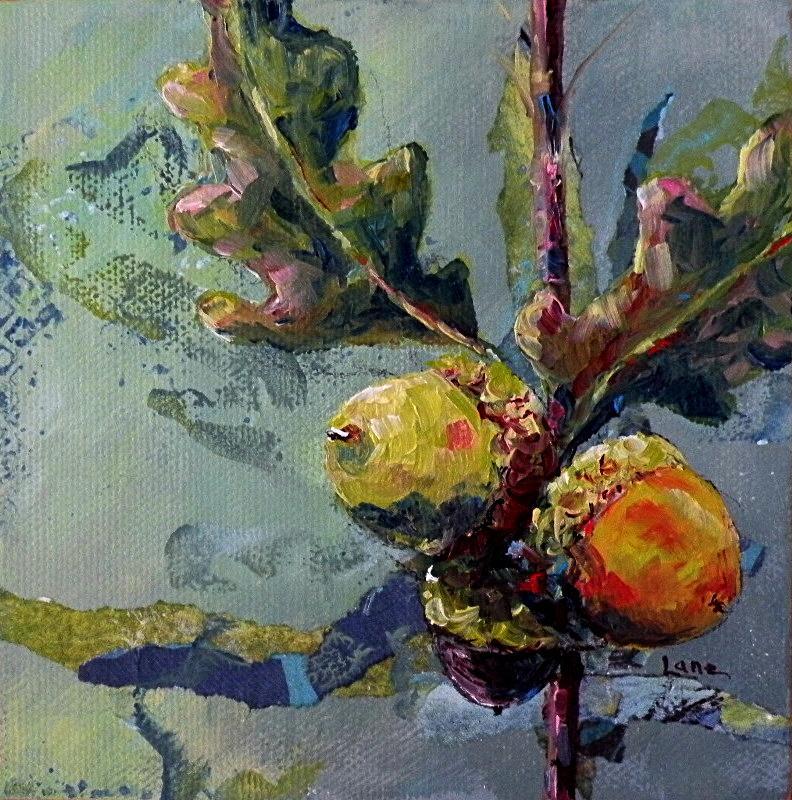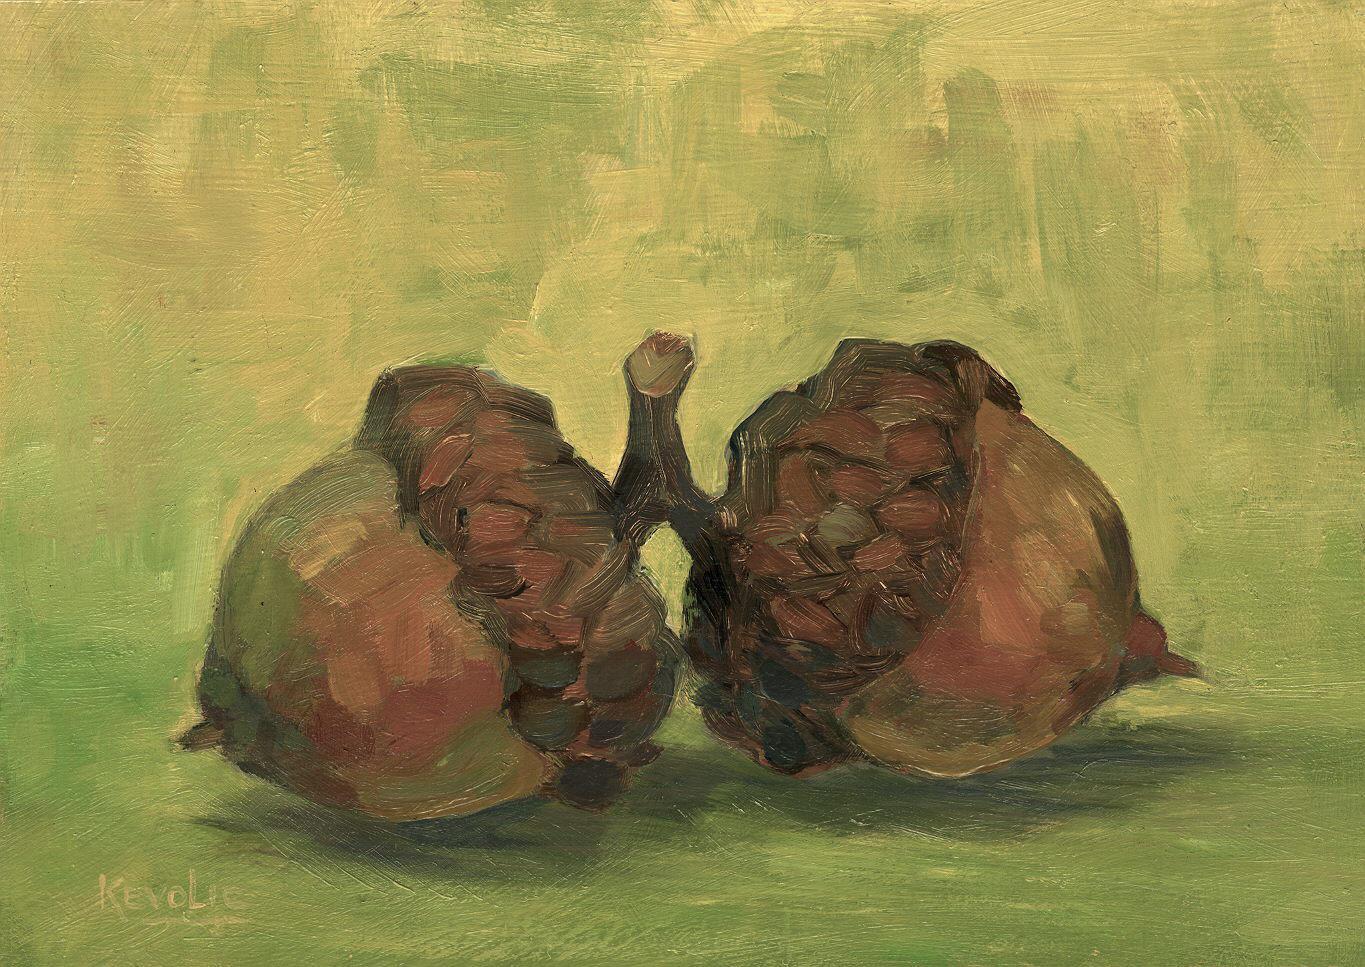The first image is the image on the left, the second image is the image on the right. Analyze the images presented: Is the assertion "There is only a single acorn it at least one of the images." valid? Answer yes or no. No. 